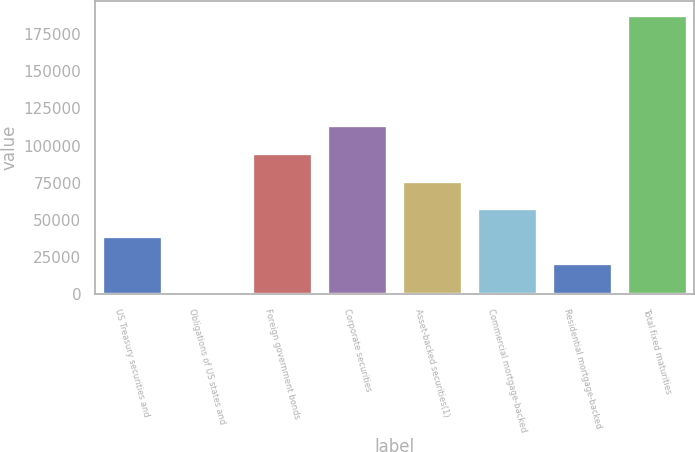<chart> <loc_0><loc_0><loc_500><loc_500><bar_chart><fcel>US Treasury securities and<fcel>Obligations of US states and<fcel>Foreign government bonds<fcel>Corporate securities<fcel>Asset-backed securities(1)<fcel>Commercial mortgage-backed<fcel>Residential mortgage-backed<fcel>Total fixed maturities<nl><fcel>39354<fcel>2254<fcel>95004<fcel>113554<fcel>76454<fcel>57904<fcel>20804<fcel>187754<nl></chart> 